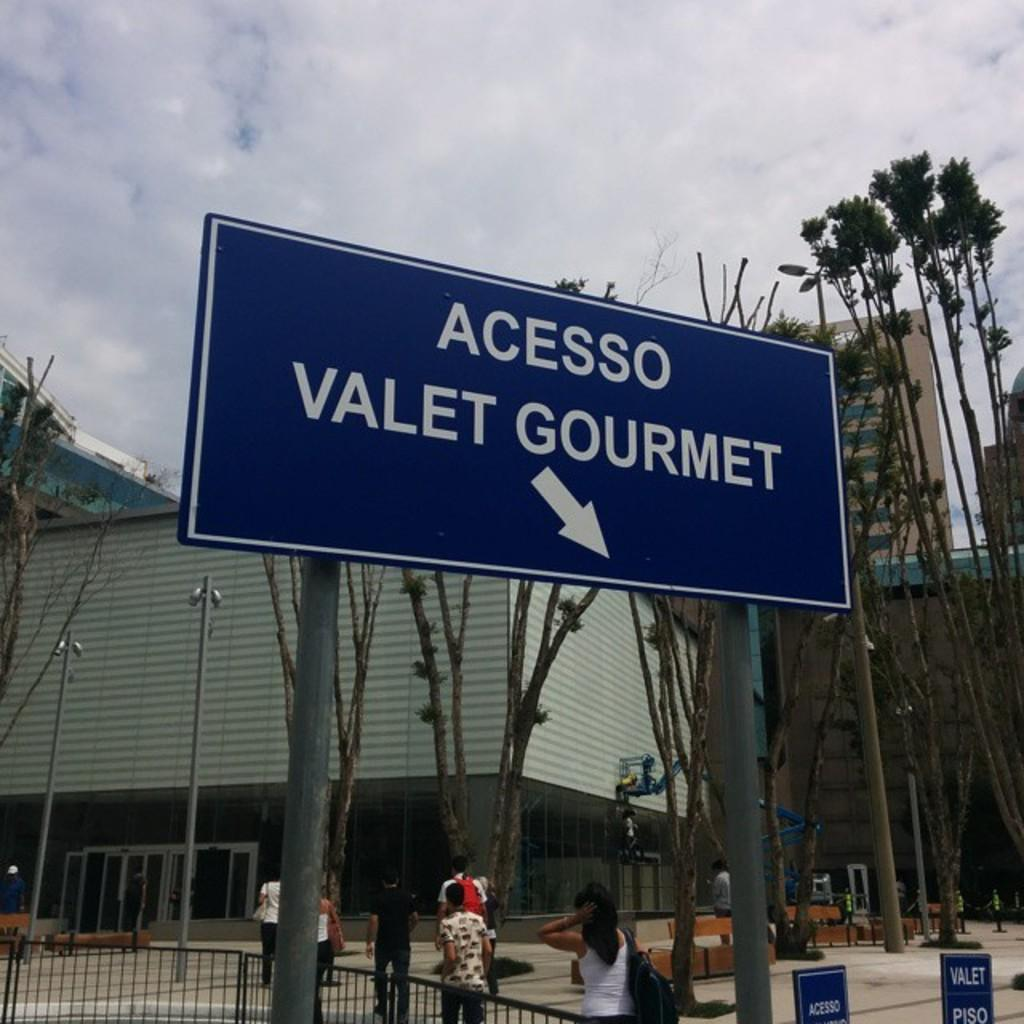<image>
Give a short and clear explanation of the subsequent image. a sign reads Acesso Valet Gourmet in front of a building 